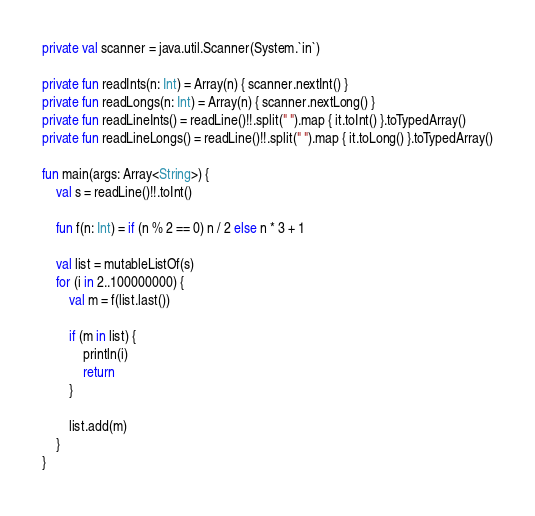Convert code to text. <code><loc_0><loc_0><loc_500><loc_500><_Kotlin_>private val scanner = java.util.Scanner(System.`in`)

private fun readInts(n: Int) = Array(n) { scanner.nextInt() }
private fun readLongs(n: Int) = Array(n) { scanner.nextLong() }
private fun readLineInts() = readLine()!!.split(" ").map { it.toInt() }.toTypedArray()
private fun readLineLongs() = readLine()!!.split(" ").map { it.toLong() }.toTypedArray()

fun main(args: Array<String>) {
    val s = readLine()!!.toInt()

    fun f(n: Int) = if (n % 2 == 0) n / 2 else n * 3 + 1

    val list = mutableListOf(s)
    for (i in 2..100000000) {
        val m = f(list.last())

        if (m in list) {
            println(i)
            return
        }

        list.add(m)
    }
}</code> 